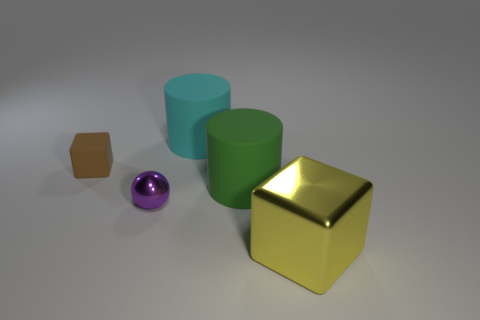What materials appear to be represented in the objects in the image? The objects appear to represent materials such as matte wood for the small brown block, a shiny metallic surface for both the tiny sphere and the larger gold cube, and matte finishes for the green cylindrical objects. 